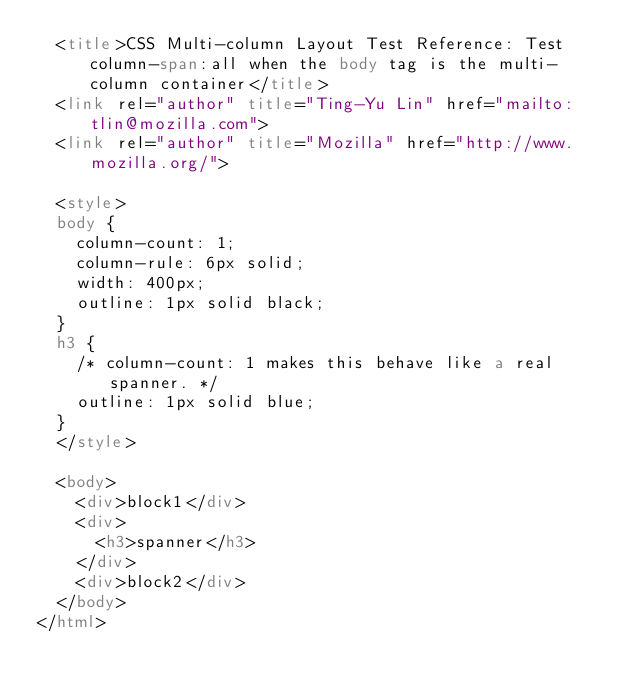Convert code to text. <code><loc_0><loc_0><loc_500><loc_500><_HTML_>  <title>CSS Multi-column Layout Test Reference: Test column-span:all when the body tag is the multi-column container</title>
  <link rel="author" title="Ting-Yu Lin" href="mailto:tlin@mozilla.com">
  <link rel="author" title="Mozilla" href="http://www.mozilla.org/">

  <style>
  body {
    column-count: 1;
    column-rule: 6px solid;
    width: 400px;
    outline: 1px solid black;
  }
  h3 {
    /* column-count: 1 makes this behave like a real spanner. */
    outline: 1px solid blue;
  }
  </style>

  <body>
    <div>block1</div>
    <div>
      <h3>spanner</h3>
    </div>
    <div>block2</div>
  </body>
</html>
</code> 